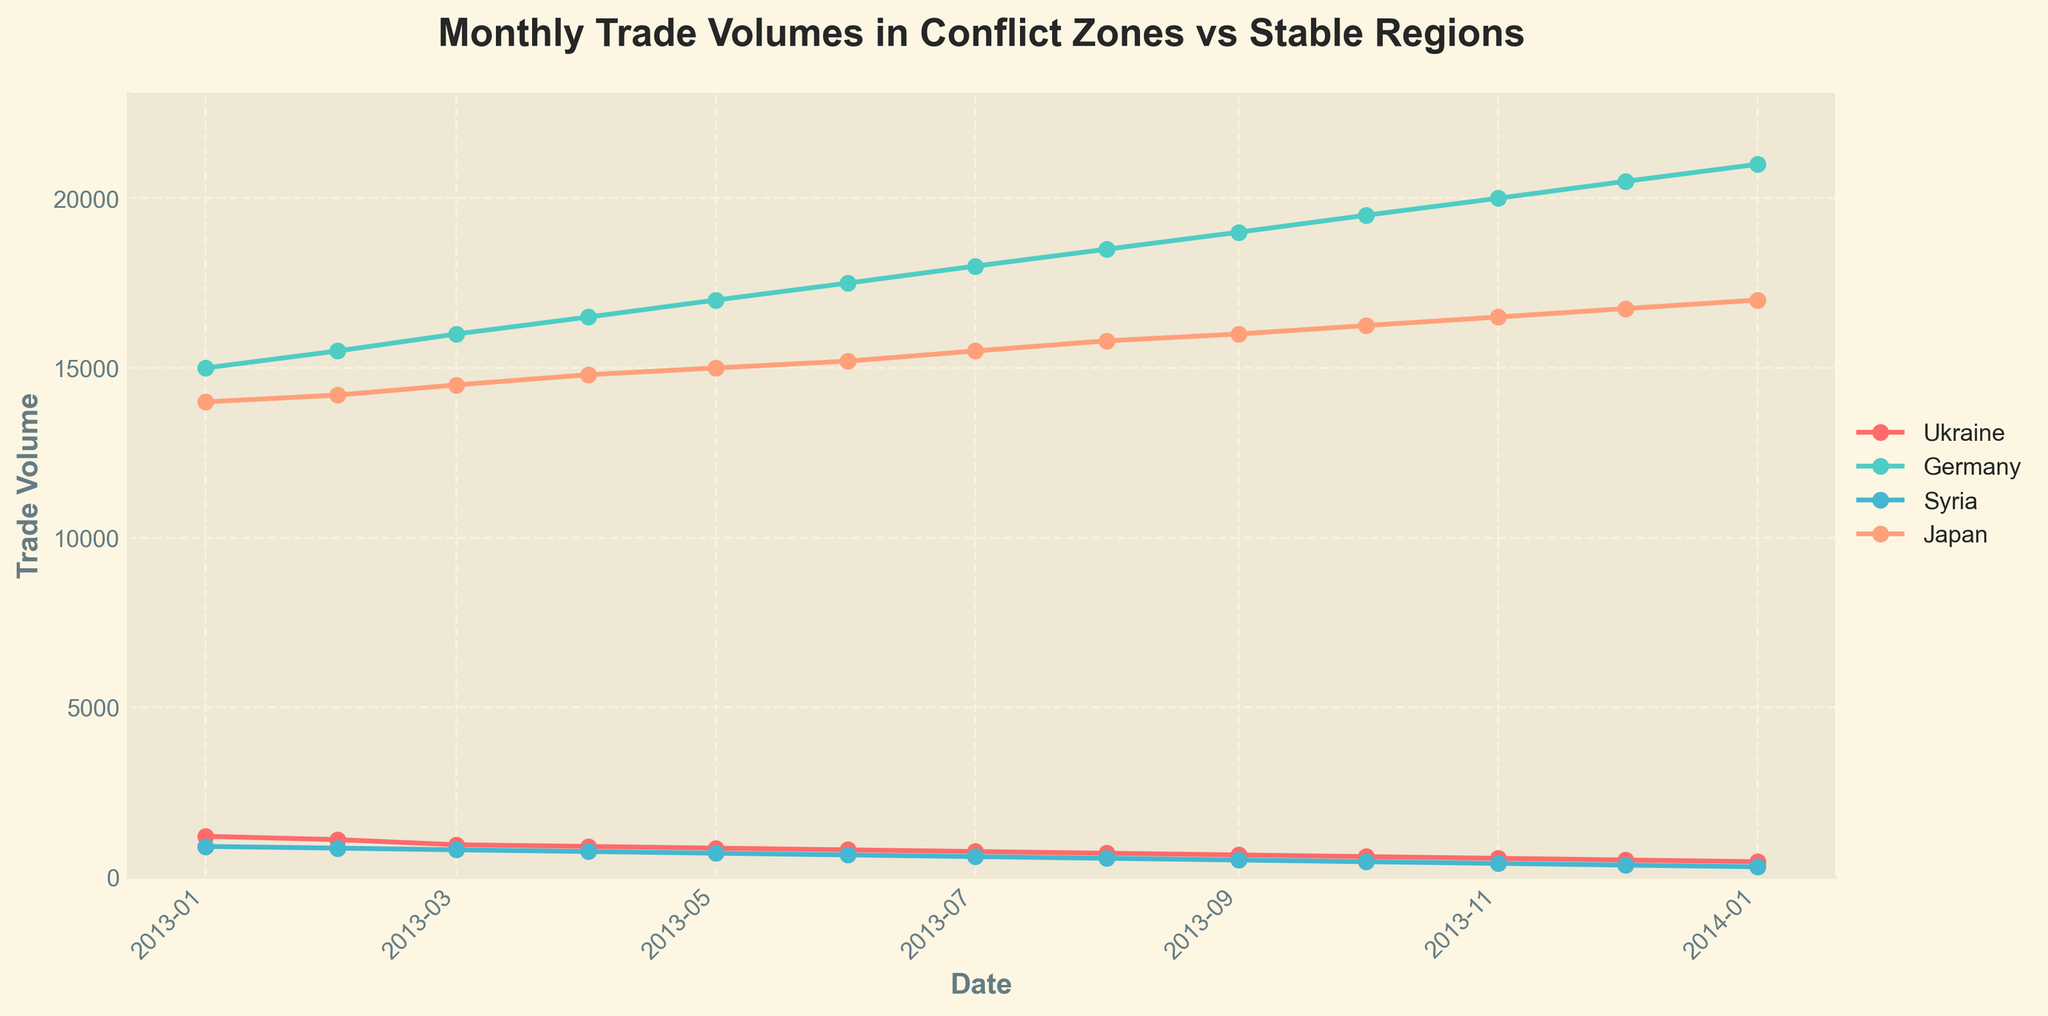what is the title of the figure? The figure's title is displayed at the top of the plot and provides an overview of the data presented. The title helps understand the context without looking at specific data points.
Answer: "Monthly Trade Volumes in Conflict Zones vs Stable Regions" How many unique locations are represented in the figure? By examining the legend or unique lines in the plot, we can count the distinct colors or labels representing different locations.
Answer: 4 Which location has the lowest trade volume in January 2013? By identifying the trade volumes for each location in January 2013 (the first set of data points), the one with the lowest value can be determined.
Answer: Syria What is the trend for Ukraine's trade volume from January 2013 to January 2014? Observing the line corresponding to Ukraine from left to right (from January 2013 to January 2014) will show whether the trade volume is increasing, decreasing, or fluctuating.
Answer: Decreasing In what month did Syria's trade volume drop below 500 for the first time? By following Syria's data points in chronological order, identify the first instance when the trade volume value is below 500.
Answer: September 2013 What is the maximum trade volume recorded for Germany within the presented timeframe? Locate the highest point on Germany's line in the plot and read the corresponding trade volume.
Answer: 21000 Compare the trade volume trends between Japan and Germany. Which location shows a more consistent increase? Examine and compare the lines corresponding to Japan and Germany. A consistent increase will show a steadily upward-sloping line.
Answer: Germany What is the difference between the trade volumes of Syria and Japan in December 2013? Find Syria's and Japan's trade volumes for December 2013 and subtract Syria's value from Japan's.
Answer: 16400 On average, how much did the trade volume in Ukraine change from one month to the next throughout the year 2013? Calculate the monthly differences in trade volumes for Ukraine and then find the average of these differences.
Answer: -63.64 (average monthly decrease) What general pattern do you observe for conflict zones (Ukraine and Syria) compared to stable regions (Germany and Japan)? By looking at the overall trends in the trade volume lines for conflict zones and stable regions, you can compare if they are increasing, decreasing, or stable.
Answer: Conflict zones generally show a decreasing trend, while stable regions show an increasing trend 